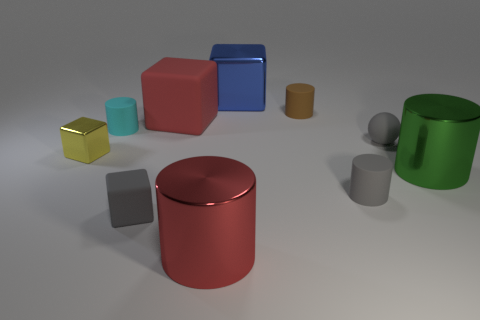Subtract all gray cylinders. How many cylinders are left? 4 Subtract all blue cubes. How many cubes are left? 3 Subtract 2 cubes. How many cubes are left? 2 Subtract all brown cylinders. Subtract all cyan blocks. How many cylinders are left? 4 Subtract all red cubes. How many purple spheres are left? 0 Subtract all brown rubber cylinders. Subtract all cubes. How many objects are left? 5 Add 7 large metallic cylinders. How many large metallic cylinders are left? 9 Add 9 small gray balls. How many small gray balls exist? 10 Subtract 0 purple cylinders. How many objects are left? 10 Subtract all balls. How many objects are left? 9 